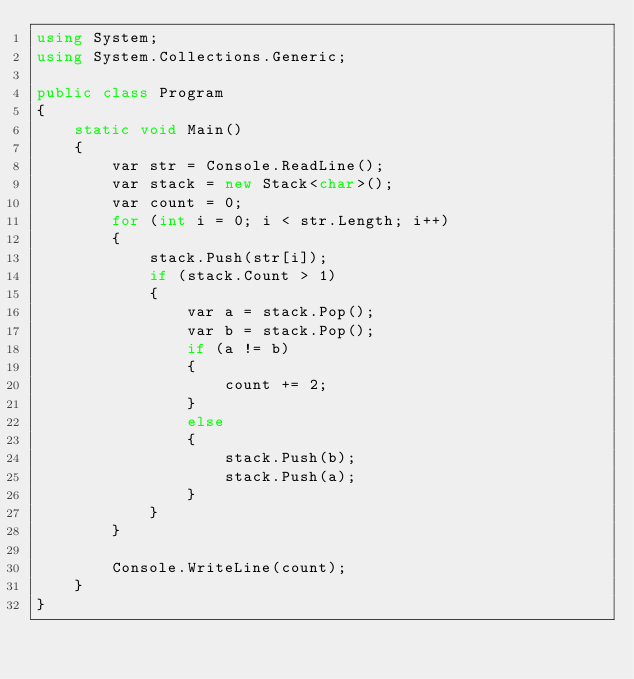Convert code to text. <code><loc_0><loc_0><loc_500><loc_500><_C#_>using System;
using System.Collections.Generic;

public class Program
{
    static void Main()
    {
        var str = Console.ReadLine();
        var stack = new Stack<char>();
        var count = 0;
        for (int i = 0; i < str.Length; i++)
        {
            stack.Push(str[i]);
            if (stack.Count > 1)
            {
                var a = stack.Pop();
                var b = stack.Pop();
                if (a != b)
                {
                    count += 2;
                }
                else
                {
                    stack.Push(b);
                    stack.Push(a);
                }
            }
        }

        Console.WriteLine(count);
    }
}
</code> 